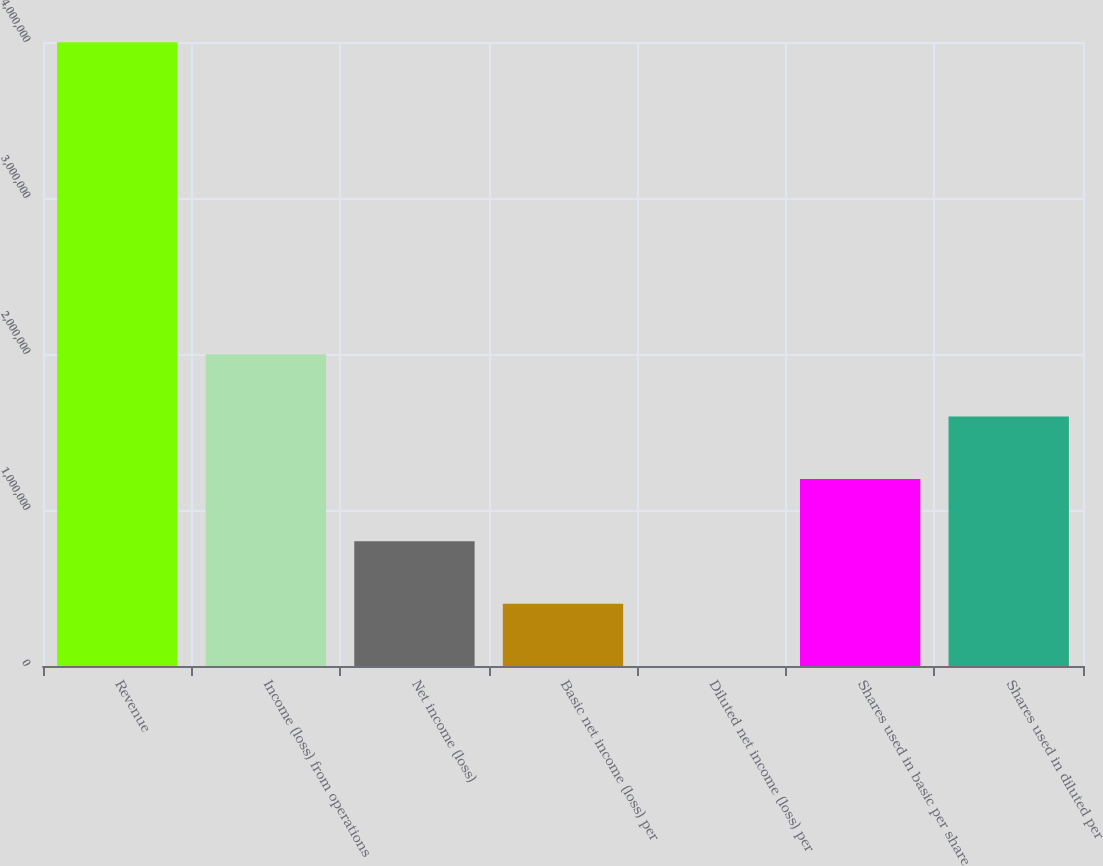Convert chart. <chart><loc_0><loc_0><loc_500><loc_500><bar_chart><fcel>Revenue<fcel>Income (loss) from operations<fcel>Net income (loss)<fcel>Basic net income (loss) per<fcel>Diluted net income (loss) per<fcel>Shares used in basic per share<fcel>Shares used in diluted per<nl><fcel>3.99793e+06<fcel>1.99897e+06<fcel>799587<fcel>399794<fcel>0.94<fcel>1.19938e+06<fcel>1.59917e+06<nl></chart> 